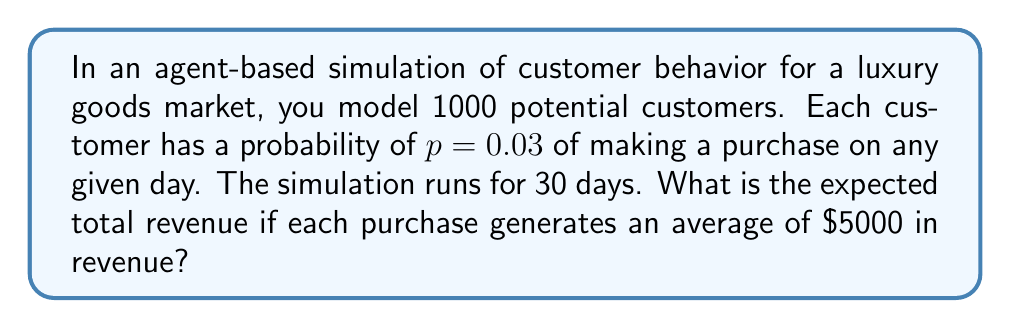What is the answer to this math problem? To solve this problem, we'll follow these steps:

1. Determine the expected number of purchases per day:
   - Number of potential customers = 1000
   - Probability of purchase per customer per day = $p = 0.03$
   - Expected purchases per day = $1000 \times 0.03 = 30$

2. Calculate the expected number of purchases over 30 days:
   - Expected purchases over 30 days = $30 \times 30 = 900$

3. Compute the expected revenue:
   - Average revenue per purchase = $5000
   - Expected total revenue = Expected purchases × Average revenue per purchase
   - Expected total revenue = $900 \times $5000 = $4,500,000

Therefore, the expected total revenue from this agent-based simulation over 30 days is $4,500,000.
Answer: $4,500,000 